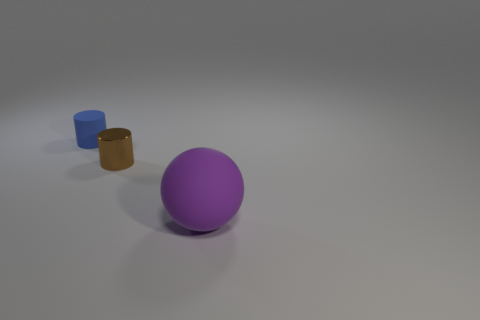How many blue matte things have the same shape as the purple matte thing? In the image, there is one blue matte cylinder that has the same shape as the purple matte sphere. 